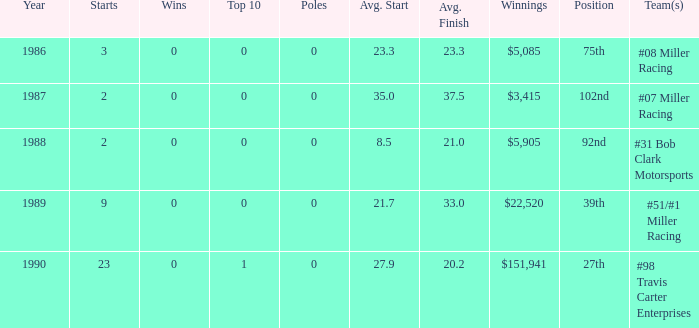How many teams finished in the top team with an average finish of 23.3? 1.0. 